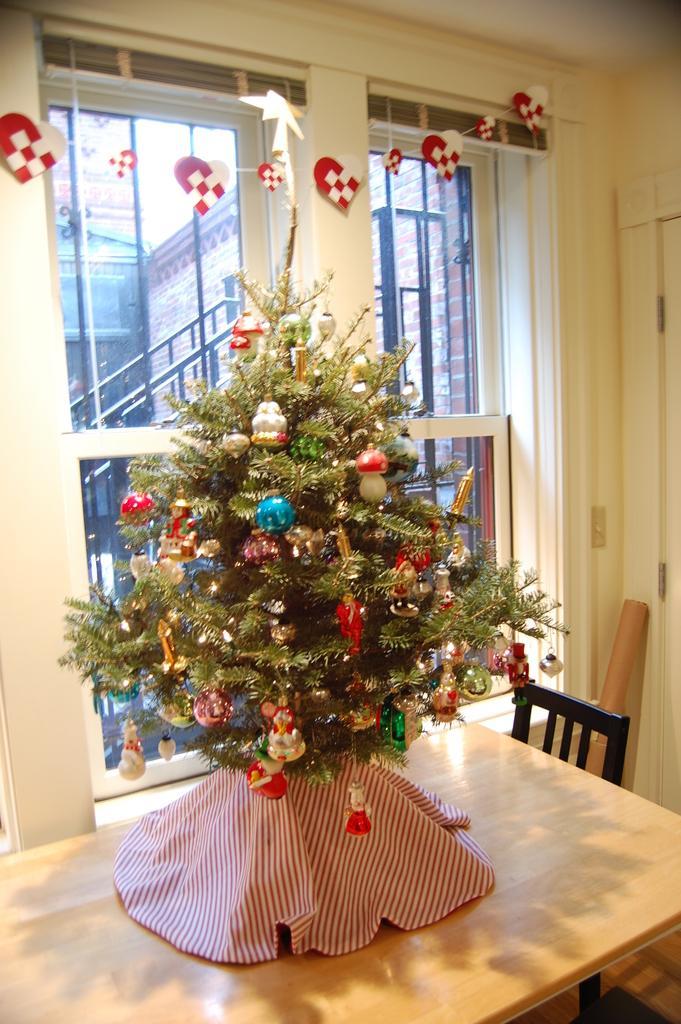How would you summarize this image in a sentence or two? On this table we can able to see a Christmas tree. Beside this table there is a chair. From this window we can able to see buildings. 